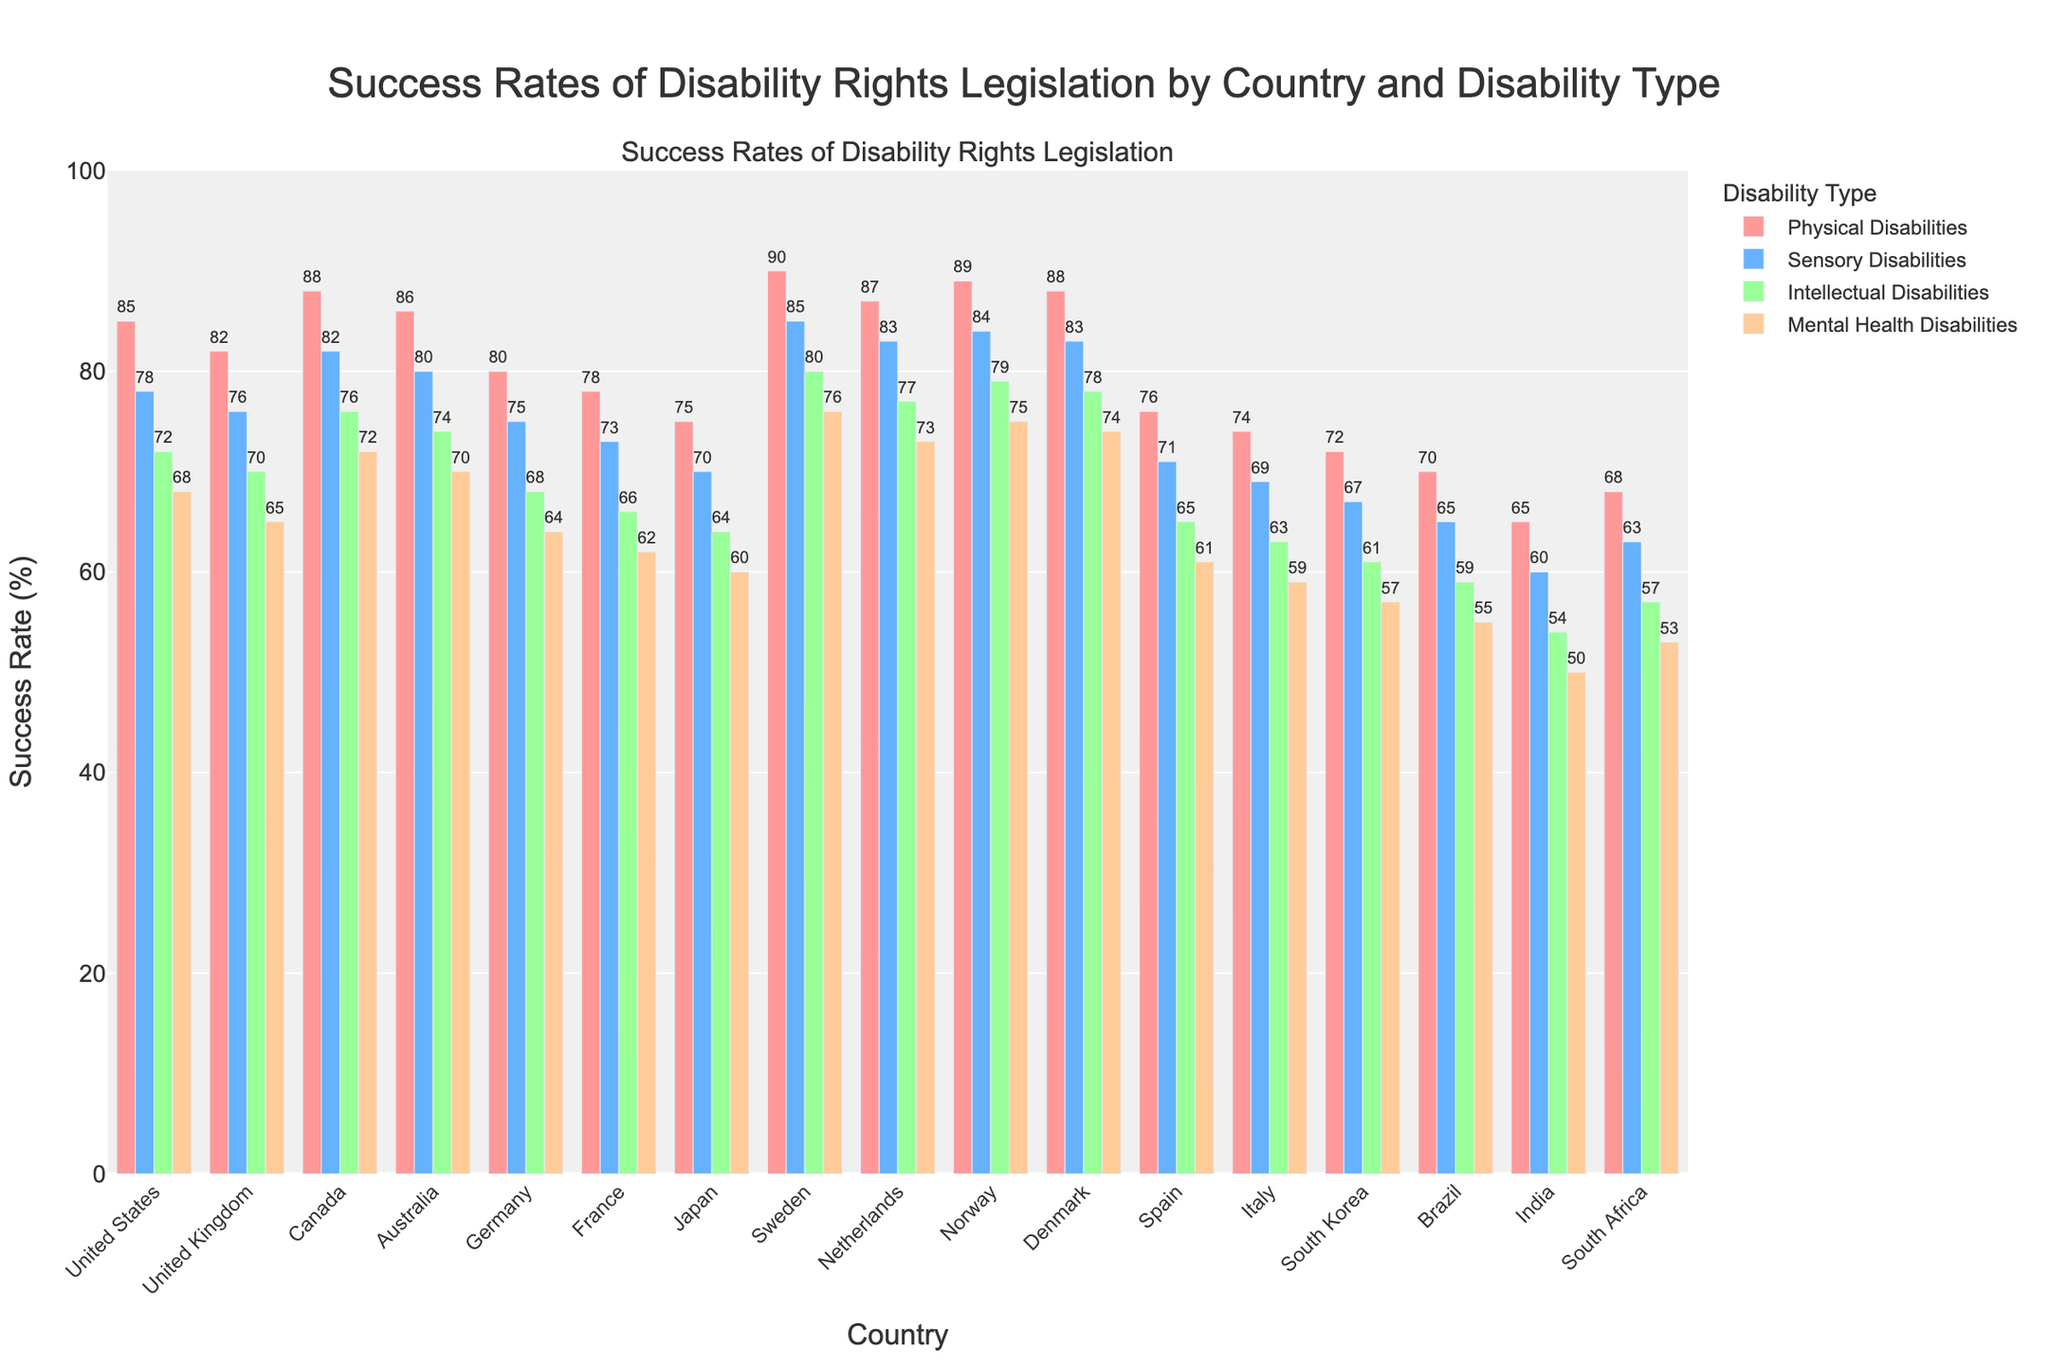Which country has the highest success rate for physical disabilities legislation? To determine the highest success rate for physical disabilities legislation, visually scan and compare the heights of the bars representing physical disabilities for each country. The highest bar is for Sweden.
Answer: Sweden Which country has the lowest success rate for intellectual disabilities legislation? To find the lowest success rate for intellectual disabilities, examine the bars for intellectual disabilities and identify the shortest one. The shortest bar is for India.
Answer: India How does the success rate for mental health disabilities in Norway compare to that in Canada? Locate the bars corresponding to mental health disabilities for both Norway and Canada. Compare their heights; Norway’s bar is slightly shorter than Canada's.
Answer: Lower What is the average success rate for sensory disabilities across all countries? Sum the sensory disabilities success rates and divide by the number of countries (17). (78+76+82+80+75+73+70+85+83+84+83+71+69+67+65+60+63) / 17 = 75.8.
Answer: 75.8 How much higher is the success rate for physical disabilities in Germany compared to South Africa? Compare the physical disabilities bars for Germany and South Africa. Germany's rate is 80, and South Africa's is 68. Subtract South Africa’s rate from Germany’s. 80 - 68 = 12.
Answer: 12 Which disability type has the most consistent success rates across countries? Look for the disability type with the least variation in bar heights across countries. Physical disabilities show relatively consistent bar heights.
Answer: Physical Disabilities By how much does the success rate for sensory disabilities differ between Japan and Italy? Compare the sensory disabilities bars for Japan and Italy. Japan's rate is 70, and Italy's is 69. Calculate the difference. 70 - 69 = 1.
Answer: 1 Which country shows the largest difference in success rates between physical and mental health disabilities? For each country, calculate the difference between physical and mental health disabilities success rates and identify the largest. For India: 65 - 50 = 15. Comparing other differences, India has the largest.
Answer: India What is the total success rate for all types of disabilities in Australia? Sum the success rates for all types in Australia. 86 + 80 + 74 + 70 = 310.
Answer: 310 Are the success rates for intellectual disabilities generally higher or lower than those for mental health disabilities? Compare the general height of the bars for intellectual disabilities and mental health disabilities across the countries. Intellectual disabilities bars tend to be higher.
Answer: Higher 